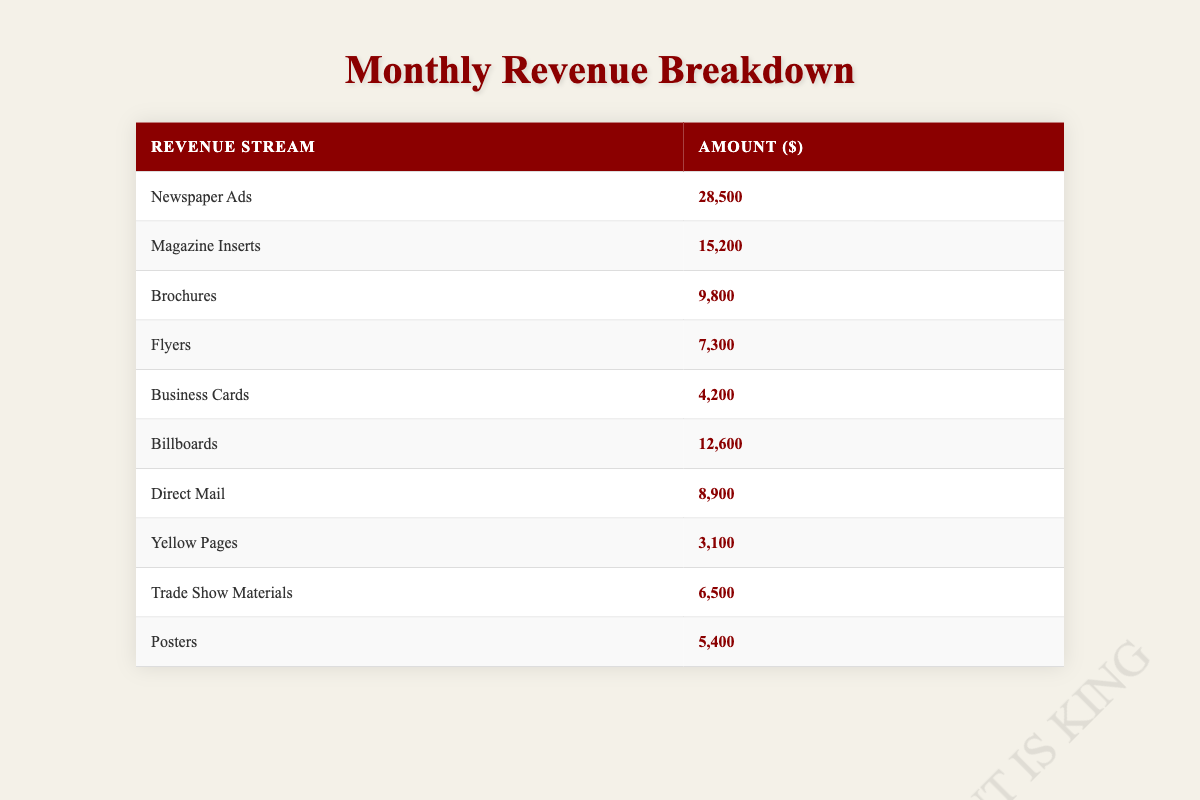What is the total amount earned from Newspaper Ads? The table shows that the amount earned from Newspaper Ads is 28,500.
Answer: 28,500 How much revenue does the agency generate from Magazine Inserts compared to Business Cards? Magazine Inserts revenue is 15,200, and Business Cards revenue is 4,200. The difference is 15,200 - 4,200 = 11,000.
Answer: 11,000 Is the revenue from Direct Mail greater than that from Flyers? The revenue from Direct Mail is 8,900 while the revenue from Flyers is 7,300. Since 8,900 is greater than 7,300, the statement is true.
Answer: Yes What is the total revenue from all sources listed in the table? To get the total revenue, sum all revenue amounts: 28,500 + 15,200 + 9,800 + 7,300 + 4,200 + 12,600 + 8,900 + 3,100 + 6,500 + 5,400 =  101,600.
Answer: 101,600 Which revenue stream has the lowest amount? By comparing all the amounts in the table, the lowest is in the Yellow Pages, which has an amount of 3,100.
Answer: 3,100 What is the average revenue of the print advertising streams listed? To find the average, sum all revenues (101,600) and divide by the number of streams (10). Therefore, 101,600 / 10 = 10,160.
Answer: 10,160 Are Billboards a higher revenue stream than Brochures? Billboards generate 12,600 while Brochures generate 9,800. Since 12,600 is more than 9,800, the statement is true.
Answer: Yes What is the difference in revenue between the highest and lowest revenue streams? The highest revenue stream is Newspaper Ads (28,500) and the lowest is Yellow Pages (3,100). The difference is calculated as 28,500 - 3,100 = 25,400.
Answer: 25,400 